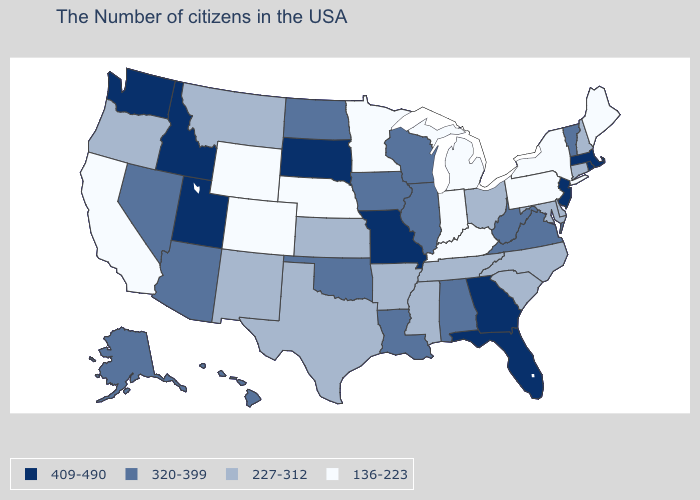What is the value of Wyoming?
Answer briefly. 136-223. Does Wisconsin have a lower value than Connecticut?
Be succinct. No. Does Ohio have a higher value than Wyoming?
Answer briefly. Yes. What is the value of Minnesota?
Write a very short answer. 136-223. Is the legend a continuous bar?
Give a very brief answer. No. Name the states that have a value in the range 320-399?
Give a very brief answer. Vermont, Virginia, West Virginia, Alabama, Wisconsin, Illinois, Louisiana, Iowa, Oklahoma, North Dakota, Arizona, Nevada, Alaska, Hawaii. What is the value of Rhode Island?
Short answer required. 409-490. What is the value of Arkansas?
Answer briefly. 227-312. What is the lowest value in the USA?
Concise answer only. 136-223. How many symbols are there in the legend?
Quick response, please. 4. What is the value of Alaska?
Concise answer only. 320-399. Name the states that have a value in the range 409-490?
Concise answer only. Massachusetts, Rhode Island, New Jersey, Florida, Georgia, Missouri, South Dakota, Utah, Idaho, Washington. Name the states that have a value in the range 320-399?
Be succinct. Vermont, Virginia, West Virginia, Alabama, Wisconsin, Illinois, Louisiana, Iowa, Oklahoma, North Dakota, Arizona, Nevada, Alaska, Hawaii. What is the value of New Hampshire?
Write a very short answer. 227-312. What is the value of Delaware?
Quick response, please. 227-312. 